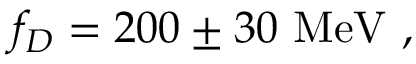<formula> <loc_0><loc_0><loc_500><loc_500>f _ { D } = 2 0 0 \pm 3 0 \ M e V \ ,</formula> 